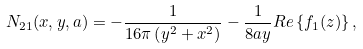<formula> <loc_0><loc_0><loc_500><loc_500>N _ { 2 1 } ( x , y , a ) = - \frac { 1 } { 1 6 \pi \left ( y ^ { 2 } + x ^ { 2 } \right ) } - \frac { 1 } { 8 a y } R e \left \{ f _ { 1 } ( z ) \right \} ,</formula> 